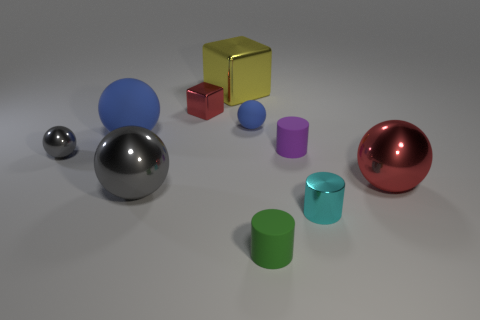Is the color of the big rubber object the same as the small matte sphere?
Provide a succinct answer. Yes. Are there fewer red shiny objects that are in front of the green rubber thing than small purple metallic things?
Your answer should be very brief. No. What size is the shiny ball to the left of the matte object left of the big gray metal ball?
Ensure brevity in your answer.  Small. There is a big matte object; is its color the same as the tiny sphere right of the big gray metallic ball?
Provide a short and direct response. Yes. There is a green thing that is the same size as the purple object; what is it made of?
Your response must be concise. Rubber. Are there fewer large yellow blocks on the right side of the tiny blue rubber object than large metal balls that are to the right of the green matte thing?
Provide a succinct answer. Yes. The gray metal object in front of the metallic sphere that is to the right of the small green object is what shape?
Offer a terse response. Sphere. Are any cylinders visible?
Provide a succinct answer. Yes. The tiny metal object behind the tiny purple cylinder is what color?
Offer a very short reply. Red. There is a small ball that is the same color as the large rubber ball; what is its material?
Offer a terse response. Rubber. 